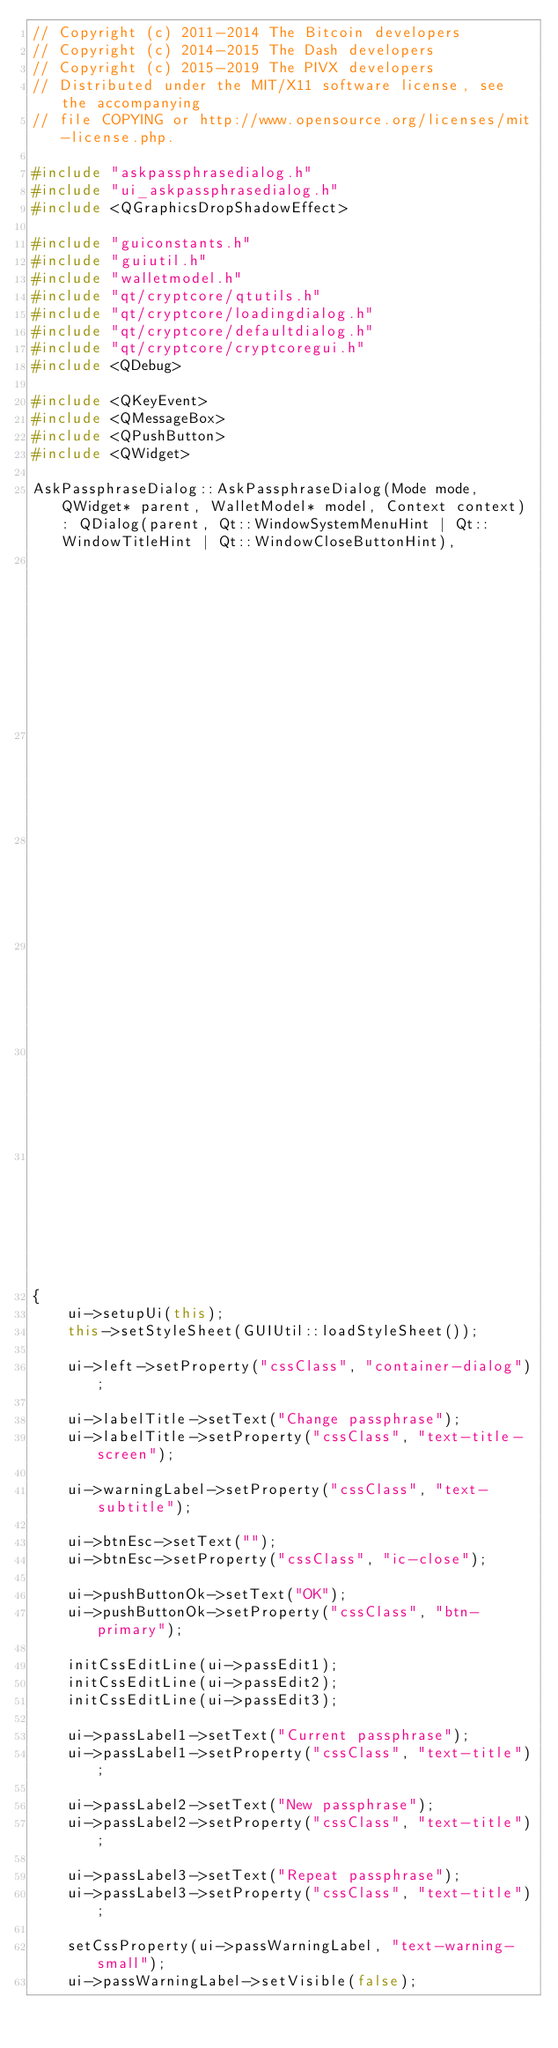Convert code to text. <code><loc_0><loc_0><loc_500><loc_500><_C++_>// Copyright (c) 2011-2014 The Bitcoin developers
// Copyright (c) 2014-2015 The Dash developers
// Copyright (c) 2015-2019 The PIVX developers
// Distributed under the MIT/X11 software license, see the accompanying
// file COPYING or http://www.opensource.org/licenses/mit-license.php.

#include "askpassphrasedialog.h"
#include "ui_askpassphrasedialog.h"
#include <QGraphicsDropShadowEffect>

#include "guiconstants.h"
#include "guiutil.h"
#include "walletmodel.h"
#include "qt/cryptcore/qtutils.h"
#include "qt/cryptcore/loadingdialog.h"
#include "qt/cryptcore/defaultdialog.h"
#include "qt/cryptcore/cryptcoregui.h"
#include <QDebug>

#include <QKeyEvent>
#include <QMessageBox>
#include <QPushButton>
#include <QWidget>

AskPassphraseDialog::AskPassphraseDialog(Mode mode, QWidget* parent, WalletModel* model, Context context) : QDialog(parent, Qt::WindowSystemMenuHint | Qt::WindowTitleHint | Qt::WindowCloseButtonHint),
                                                                                                            ui(new Ui::AskPassphraseDialog),
                                                                                                            mode(mode),
                                                                                                            model(model),
                                                                                                            context(context),
                                                                                                            fCapsLock(false),
                                                                                                            btnWatch(new QCheckBox())
{
    ui->setupUi(this);
    this->setStyleSheet(GUIUtil::loadStyleSheet());

    ui->left->setProperty("cssClass", "container-dialog");

    ui->labelTitle->setText("Change passphrase");
    ui->labelTitle->setProperty("cssClass", "text-title-screen");

    ui->warningLabel->setProperty("cssClass", "text-subtitle");

    ui->btnEsc->setText("");
    ui->btnEsc->setProperty("cssClass", "ic-close");

    ui->pushButtonOk->setText("OK");
    ui->pushButtonOk->setProperty("cssClass", "btn-primary");

    initCssEditLine(ui->passEdit1);
    initCssEditLine(ui->passEdit2);
    initCssEditLine(ui->passEdit3);

    ui->passLabel1->setText("Current passphrase");
    ui->passLabel1->setProperty("cssClass", "text-title");

    ui->passLabel2->setText("New passphrase");
    ui->passLabel2->setProperty("cssClass", "text-title");

    ui->passLabel3->setText("Repeat passphrase");
    ui->passLabel3->setProperty("cssClass", "text-title");

    setCssProperty(ui->passWarningLabel, "text-warning-small");
    ui->passWarningLabel->setVisible(false);
</code> 